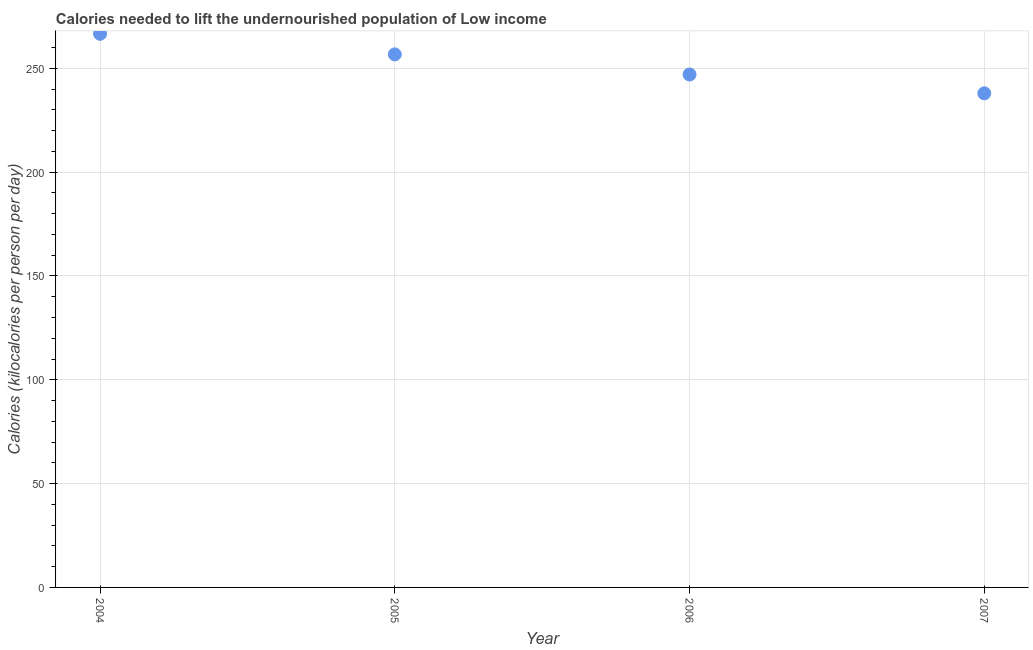What is the depth of food deficit in 2005?
Provide a short and direct response. 256.75. Across all years, what is the maximum depth of food deficit?
Give a very brief answer. 266.65. Across all years, what is the minimum depth of food deficit?
Your answer should be compact. 237.98. What is the sum of the depth of food deficit?
Keep it short and to the point. 1008.43. What is the difference between the depth of food deficit in 2004 and 2005?
Provide a short and direct response. 9.9. What is the average depth of food deficit per year?
Offer a very short reply. 252.11. What is the median depth of food deficit?
Your response must be concise. 251.9. What is the ratio of the depth of food deficit in 2004 to that in 2007?
Provide a short and direct response. 1.12. Is the depth of food deficit in 2004 less than that in 2007?
Your response must be concise. No. What is the difference between the highest and the second highest depth of food deficit?
Provide a short and direct response. 9.9. Is the sum of the depth of food deficit in 2004 and 2007 greater than the maximum depth of food deficit across all years?
Your answer should be very brief. Yes. What is the difference between the highest and the lowest depth of food deficit?
Offer a very short reply. 28.67. In how many years, is the depth of food deficit greater than the average depth of food deficit taken over all years?
Keep it short and to the point. 2. Does the depth of food deficit monotonically increase over the years?
Make the answer very short. No. How many dotlines are there?
Ensure brevity in your answer.  1. Are the values on the major ticks of Y-axis written in scientific E-notation?
Ensure brevity in your answer.  No. What is the title of the graph?
Your answer should be compact. Calories needed to lift the undernourished population of Low income. What is the label or title of the Y-axis?
Ensure brevity in your answer.  Calories (kilocalories per person per day). What is the Calories (kilocalories per person per day) in 2004?
Ensure brevity in your answer.  266.65. What is the Calories (kilocalories per person per day) in 2005?
Make the answer very short. 256.75. What is the Calories (kilocalories per person per day) in 2006?
Give a very brief answer. 247.05. What is the Calories (kilocalories per person per day) in 2007?
Keep it short and to the point. 237.98. What is the difference between the Calories (kilocalories per person per day) in 2004 and 2005?
Your answer should be compact. 9.9. What is the difference between the Calories (kilocalories per person per day) in 2004 and 2006?
Your answer should be compact. 19.6. What is the difference between the Calories (kilocalories per person per day) in 2004 and 2007?
Provide a succinct answer. 28.67. What is the difference between the Calories (kilocalories per person per day) in 2005 and 2006?
Your answer should be compact. 9.7. What is the difference between the Calories (kilocalories per person per day) in 2005 and 2007?
Make the answer very short. 18.77. What is the difference between the Calories (kilocalories per person per day) in 2006 and 2007?
Provide a succinct answer. 9.07. What is the ratio of the Calories (kilocalories per person per day) in 2004 to that in 2005?
Ensure brevity in your answer.  1.04. What is the ratio of the Calories (kilocalories per person per day) in 2004 to that in 2006?
Offer a terse response. 1.08. What is the ratio of the Calories (kilocalories per person per day) in 2004 to that in 2007?
Ensure brevity in your answer.  1.12. What is the ratio of the Calories (kilocalories per person per day) in 2005 to that in 2006?
Provide a short and direct response. 1.04. What is the ratio of the Calories (kilocalories per person per day) in 2005 to that in 2007?
Give a very brief answer. 1.08. What is the ratio of the Calories (kilocalories per person per day) in 2006 to that in 2007?
Offer a terse response. 1.04. 